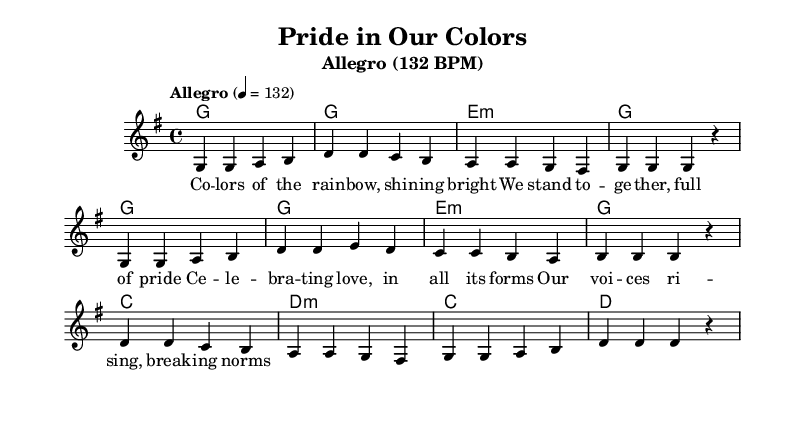What is the key signature of this music? The key signature is G major, which has one sharp (F#). This can be determined by looking at the key signature indicated at the beginning of the score.
Answer: G major What is the time signature of this music? The time signature is 4/4, which is indicated at the beginning of the score. This means there are four beats in each measure and the quarter note gets one beat.
Answer: 4/4 What is the tempo marking of the piece? The tempo marking is Allegro, with a speed of 132 beats per minute indicated in the tempo during the score. This sets a lively pace for the music.
Answer: Allegro (132 BPM) What is the structure of the song in terms of harmony? The structure consists of a repeating pattern of G, E minor, C, and D minor chords, creating a typical pop harmonic progression. This can be seen in the harmonies section of the score.
Answer: G, E minor, C, D minor Identify a key theme in the lyrics presented in the score. The key theme is celebrating love and pride, as expressed through the lyrics that emphasize unity and breaking norms, indicative of LGBTQ+ empowerment. This theme is interwoven throughout the lyrical content.
Answer: Celebrating love and pride What kind of song is this considered to be based on the lyrics? This song is considered an anthem, as it conveys a message of empowerment and celebration of LGBTQ+ identity, which is characteristic of upbeat pop anthems.
Answer: Anthem 